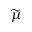Convert formula to latex. <formula><loc_0><loc_0><loc_500><loc_500>\widetilde { \mu }</formula> 